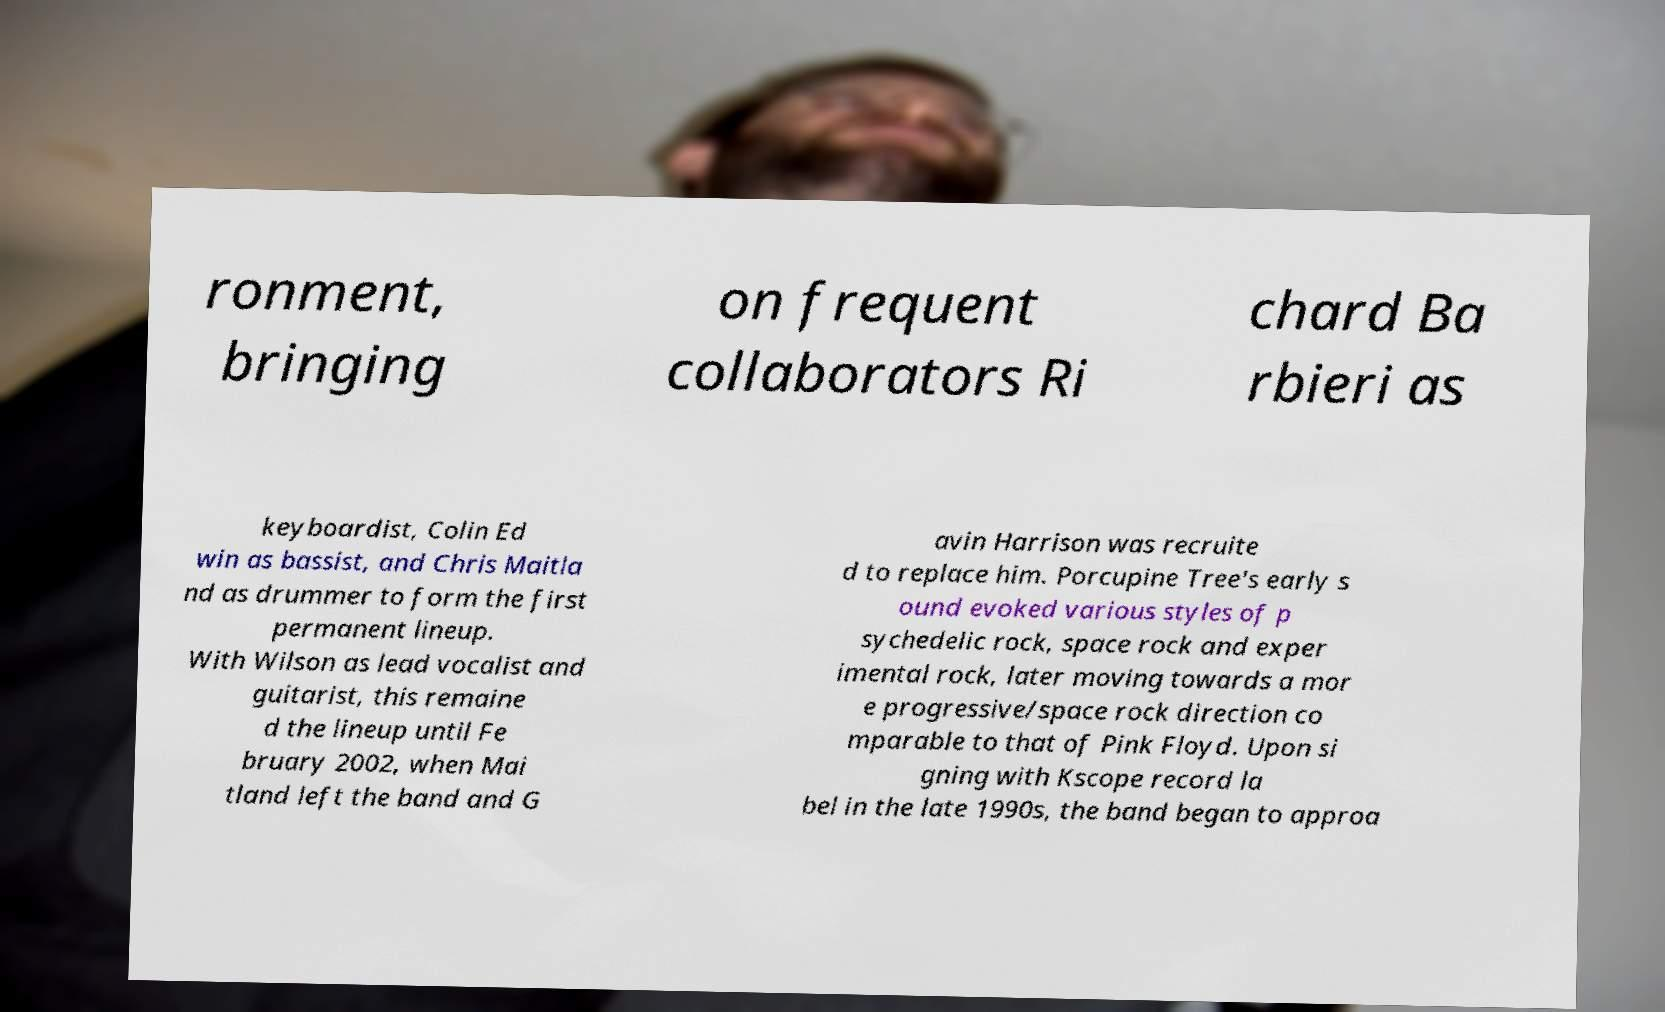Please identify and transcribe the text found in this image. ronment, bringing on frequent collaborators Ri chard Ba rbieri as keyboardist, Colin Ed win as bassist, and Chris Maitla nd as drummer to form the first permanent lineup. With Wilson as lead vocalist and guitarist, this remaine d the lineup until Fe bruary 2002, when Mai tland left the band and G avin Harrison was recruite d to replace him. Porcupine Tree's early s ound evoked various styles of p sychedelic rock, space rock and exper imental rock, later moving towards a mor e progressive/space rock direction co mparable to that of Pink Floyd. Upon si gning with Kscope record la bel in the late 1990s, the band began to approa 